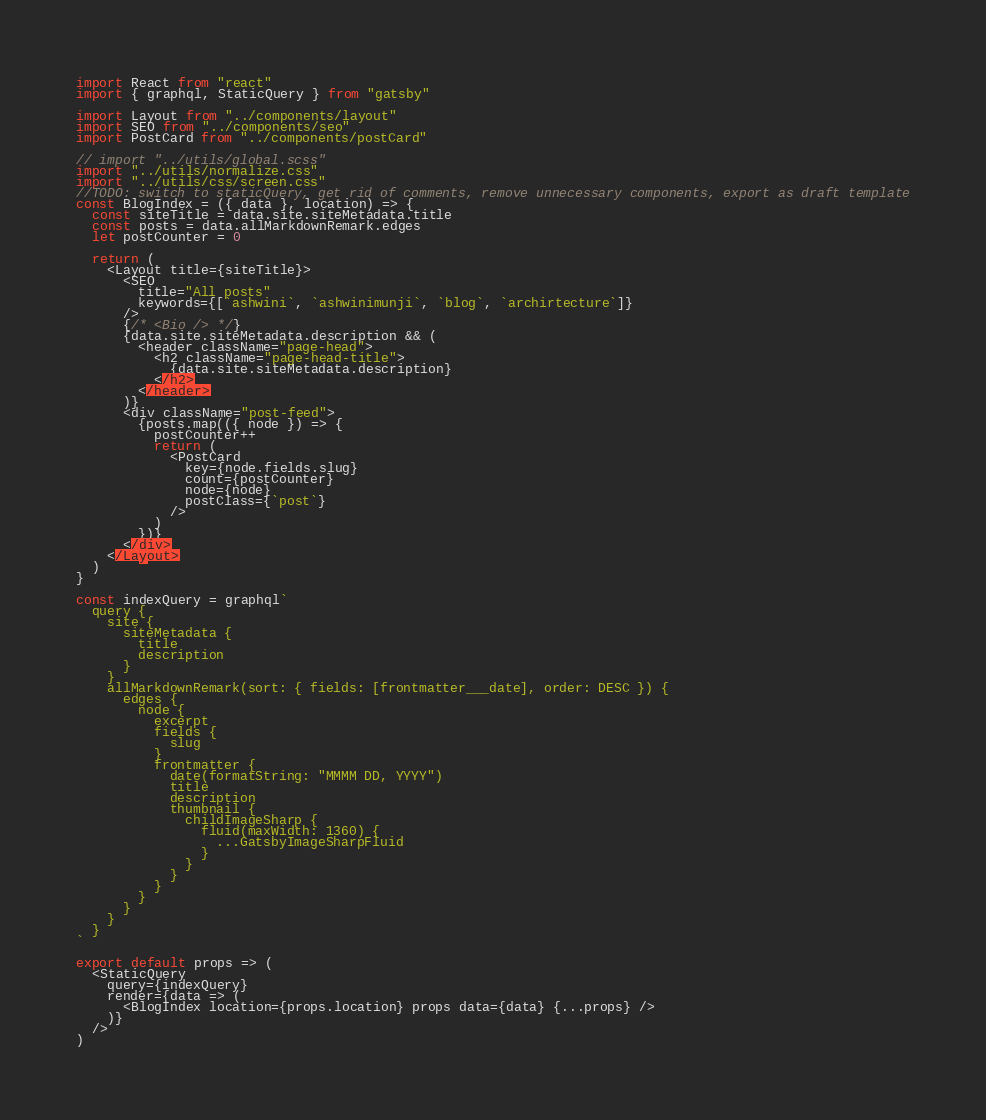Convert code to text. <code><loc_0><loc_0><loc_500><loc_500><_JavaScript_>import React from "react"
import { graphql, StaticQuery } from "gatsby"

import Layout from "../components/layout"
import SEO from "../components/seo"
import PostCard from "../components/postCard"

// import "../utils/global.scss"
import "../utils/normalize.css"
import "../utils/css/screen.css"
//TODO: switch to staticQuery, get rid of comments, remove unnecessary components, export as draft template
const BlogIndex = ({ data }, location) => {
  const siteTitle = data.site.siteMetadata.title
  const posts = data.allMarkdownRemark.edges
  let postCounter = 0

  return (
    <Layout title={siteTitle}>
      <SEO
        title="All posts"
        keywords={[`ashwini`, `ashwinimunji`, `blog`, `archirtecture`]}
      />
      {/* <Bio /> */}
      {data.site.siteMetadata.description && (
        <header className="page-head">
          <h2 className="page-head-title">
            {data.site.siteMetadata.description}
          </h2>
        </header>
      )}
      <div className="post-feed">
        {posts.map(({ node }) => {
          postCounter++
          return (
            <PostCard
              key={node.fields.slug}
              count={postCounter}
              node={node}
              postClass={`post`}
            />
          )
        })}
      </div>
    </Layout>
  )
}

const indexQuery = graphql`
  query {
    site {
      siteMetadata {
        title
        description
      }
    }
    allMarkdownRemark(sort: { fields: [frontmatter___date], order: DESC }) {
      edges {
        node {
          excerpt
          fields {
            slug
          }
          frontmatter {
            date(formatString: "MMMM DD, YYYY")
            title
            description
            thumbnail {
              childImageSharp {
                fluid(maxWidth: 1360) {
                  ...GatsbyImageSharpFluid
                }
              }
            }
          }
        }
      }
    }
  }
`

export default props => (
  <StaticQuery
    query={indexQuery}
    render={data => (
      <BlogIndex location={props.location} props data={data} {...props} />
    )}
  />
)
</code> 